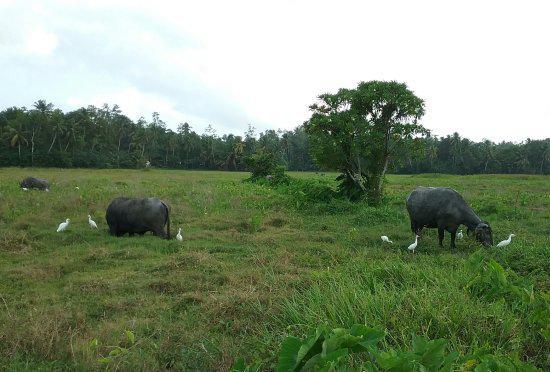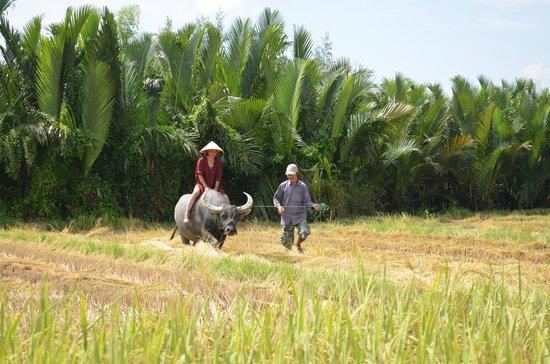The first image is the image on the left, the second image is the image on the right. Analyze the images presented: Is the assertion "There is no more than one water buffalo in the right image." valid? Answer yes or no. Yes. The first image is the image on the left, the second image is the image on the right. For the images displayed, is the sentence "At least one image shows a team of two oxen pulling a plow with a man behind it." factually correct? Answer yes or no. No. 